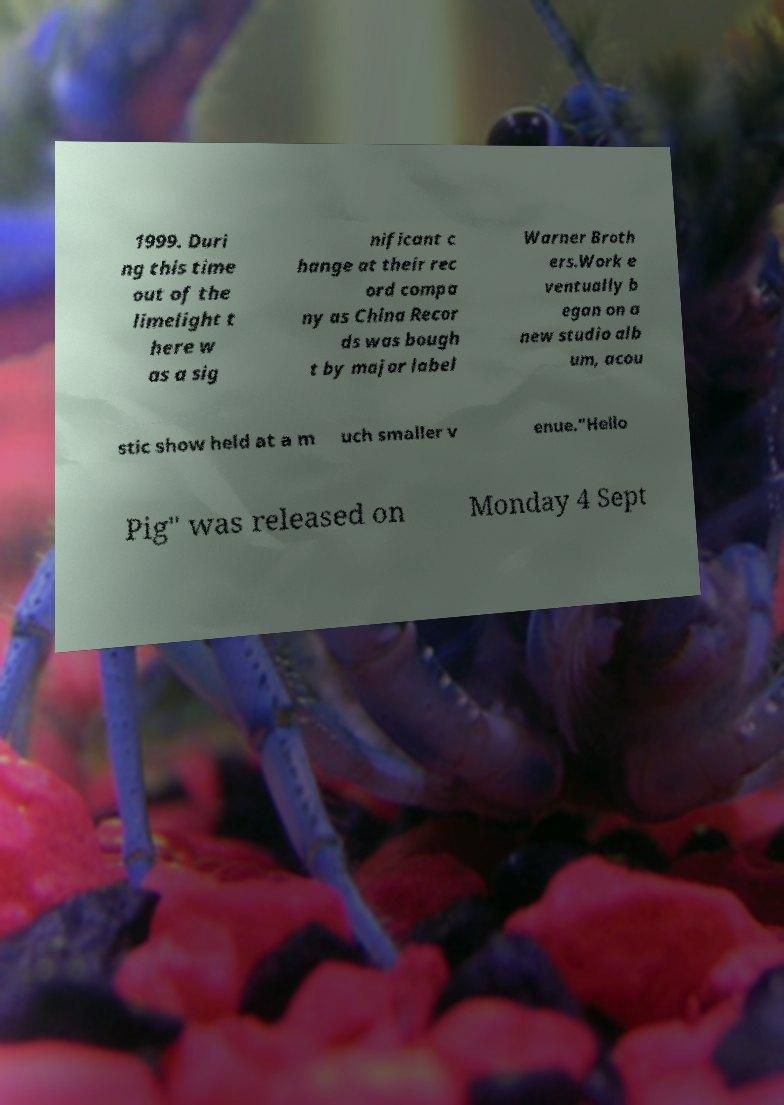Please read and relay the text visible in this image. What does it say? 1999. Duri ng this time out of the limelight t here w as a sig nificant c hange at their rec ord compa ny as China Recor ds was bough t by major label Warner Broth ers.Work e ventually b egan on a new studio alb um, acou stic show held at a m uch smaller v enue."Hello Pig" was released on Monday 4 Sept 